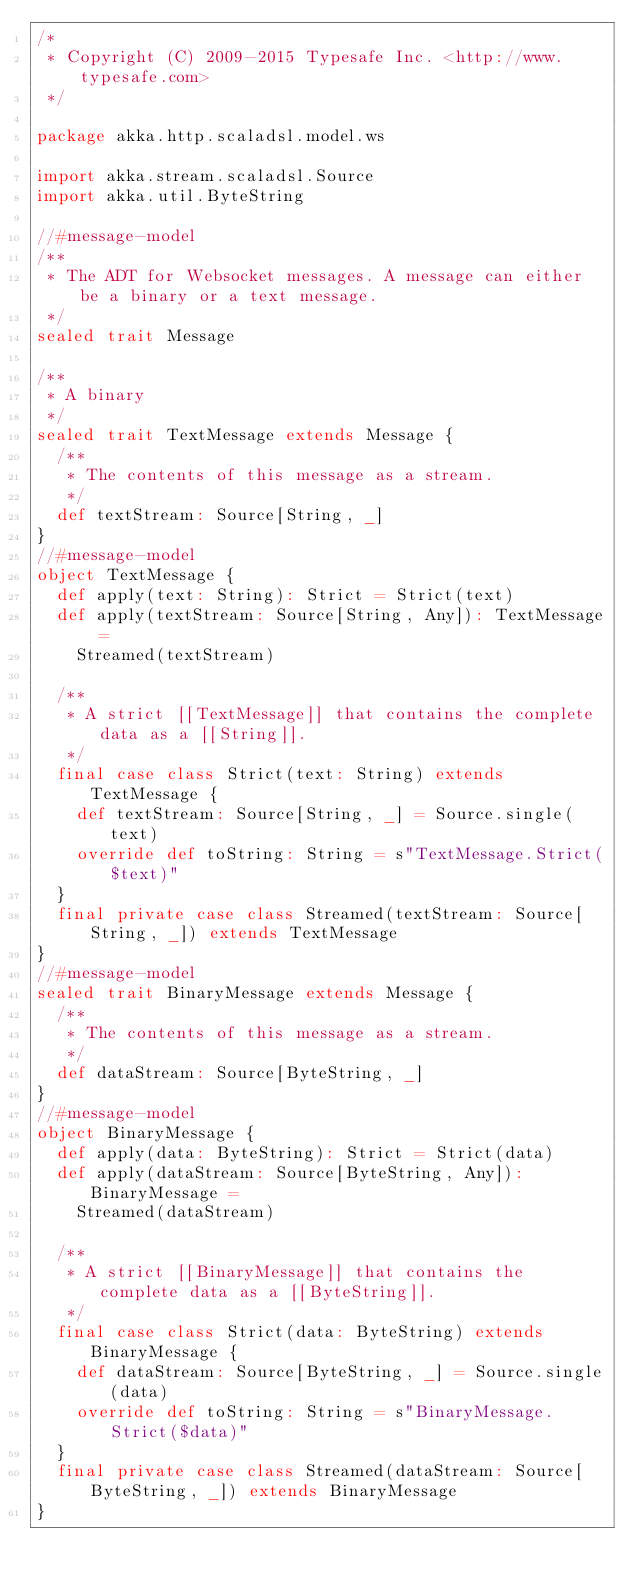Convert code to text. <code><loc_0><loc_0><loc_500><loc_500><_Scala_>/*
 * Copyright (C) 2009-2015 Typesafe Inc. <http://www.typesafe.com>
 */

package akka.http.scaladsl.model.ws

import akka.stream.scaladsl.Source
import akka.util.ByteString

//#message-model
/**
 * The ADT for Websocket messages. A message can either be a binary or a text message.
 */
sealed trait Message

/**
 * A binary
 */
sealed trait TextMessage extends Message {
  /**
   * The contents of this message as a stream.
   */
  def textStream: Source[String, _]
}
//#message-model
object TextMessage {
  def apply(text: String): Strict = Strict(text)
  def apply(textStream: Source[String, Any]): TextMessage =
    Streamed(textStream)

  /**
   * A strict [[TextMessage]] that contains the complete data as a [[String]].
   */
  final case class Strict(text: String) extends TextMessage {
    def textStream: Source[String, _] = Source.single(text)
    override def toString: String = s"TextMessage.Strict($text)"
  }
  final private case class Streamed(textStream: Source[String, _]) extends TextMessage
}
//#message-model
sealed trait BinaryMessage extends Message {
  /**
   * The contents of this message as a stream.
   */
  def dataStream: Source[ByteString, _]
}
//#message-model
object BinaryMessage {
  def apply(data: ByteString): Strict = Strict(data)
  def apply(dataStream: Source[ByteString, Any]): BinaryMessage =
    Streamed(dataStream)

  /**
   * A strict [[BinaryMessage]] that contains the complete data as a [[ByteString]].
   */
  final case class Strict(data: ByteString) extends BinaryMessage {
    def dataStream: Source[ByteString, _] = Source.single(data)
    override def toString: String = s"BinaryMessage.Strict($data)"
  }
  final private case class Streamed(dataStream: Source[ByteString, _]) extends BinaryMessage
}</code> 